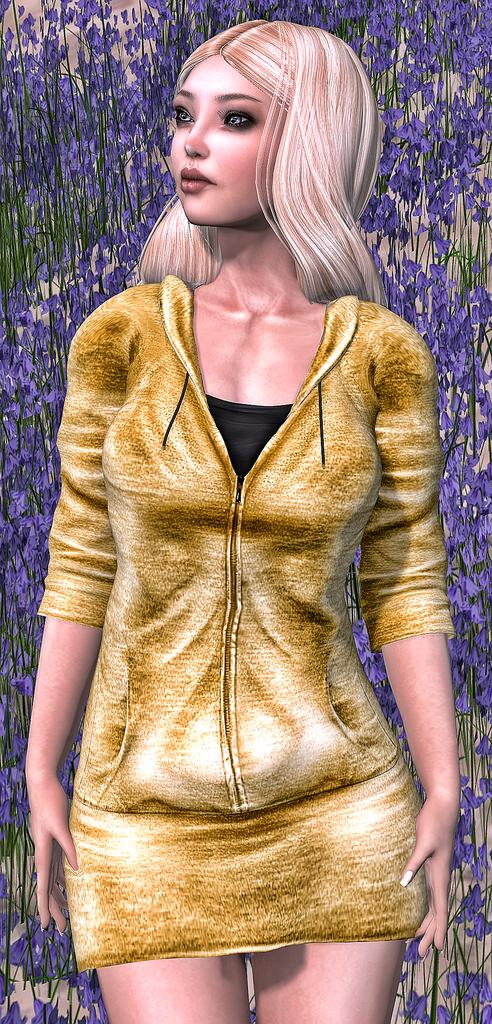What type of image is being described? The image is animated. Can you describe the main subject in the image? There is a person in the image. What can be seen in the background of the image? There is an object in the background that looks like a curtain. What type of plantation is visible in the image? There is no plantation present in the image. How does the person's growth change throughout the animation? The image does not depict any growth or change in the person's size or appearance. 